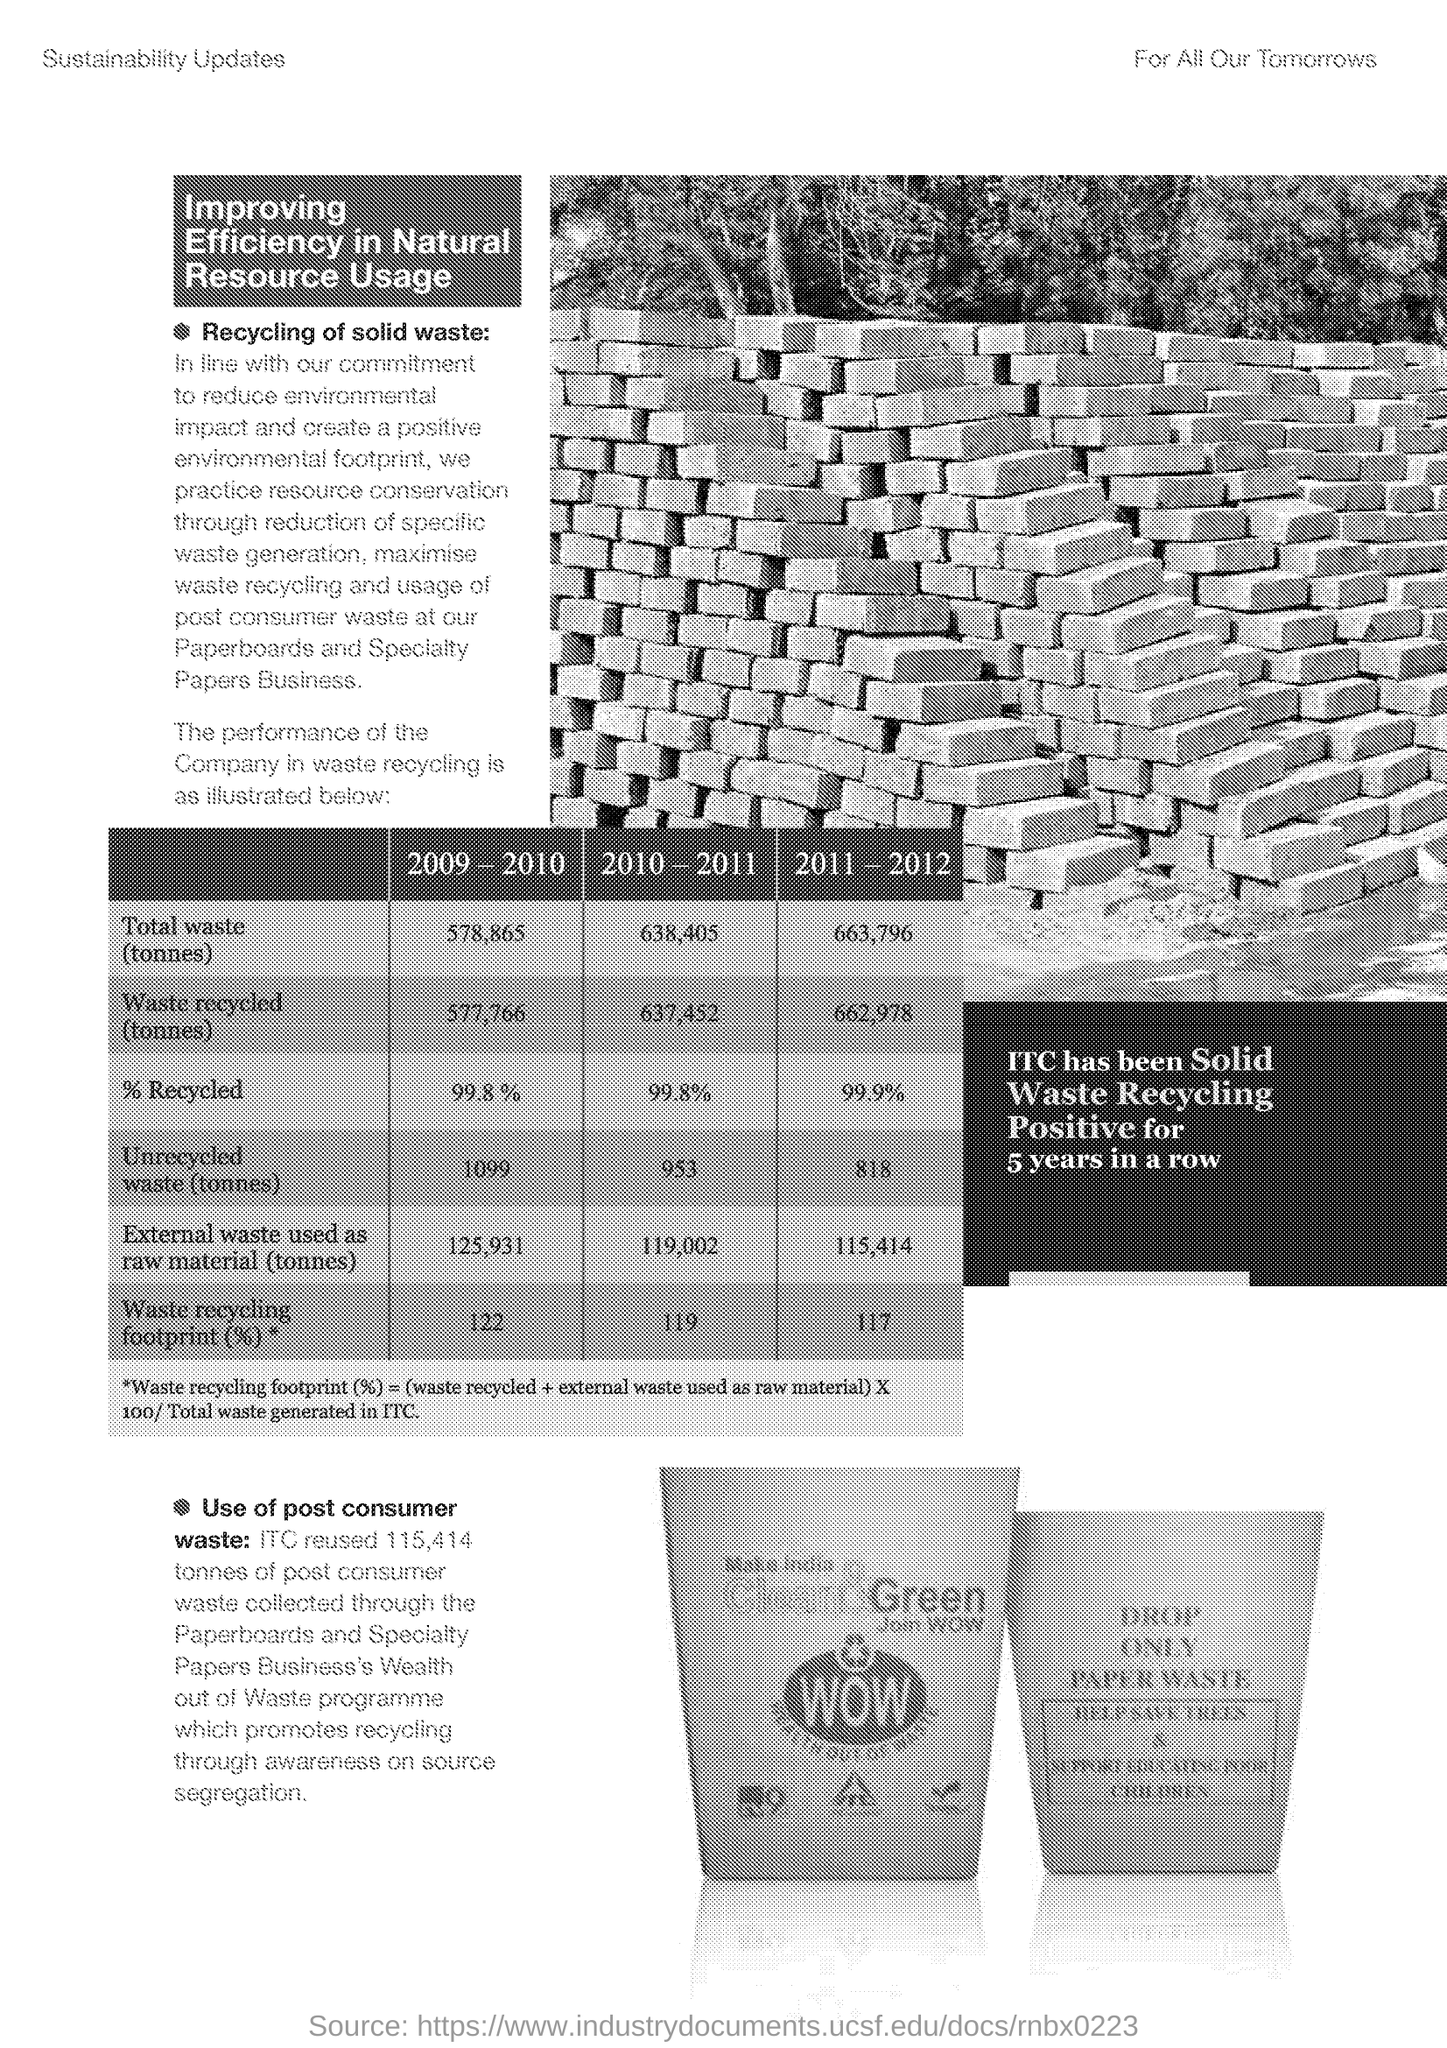What is the % of waste recycling footprint for the year 2010-2011 ?
Give a very brief answer. 119. 